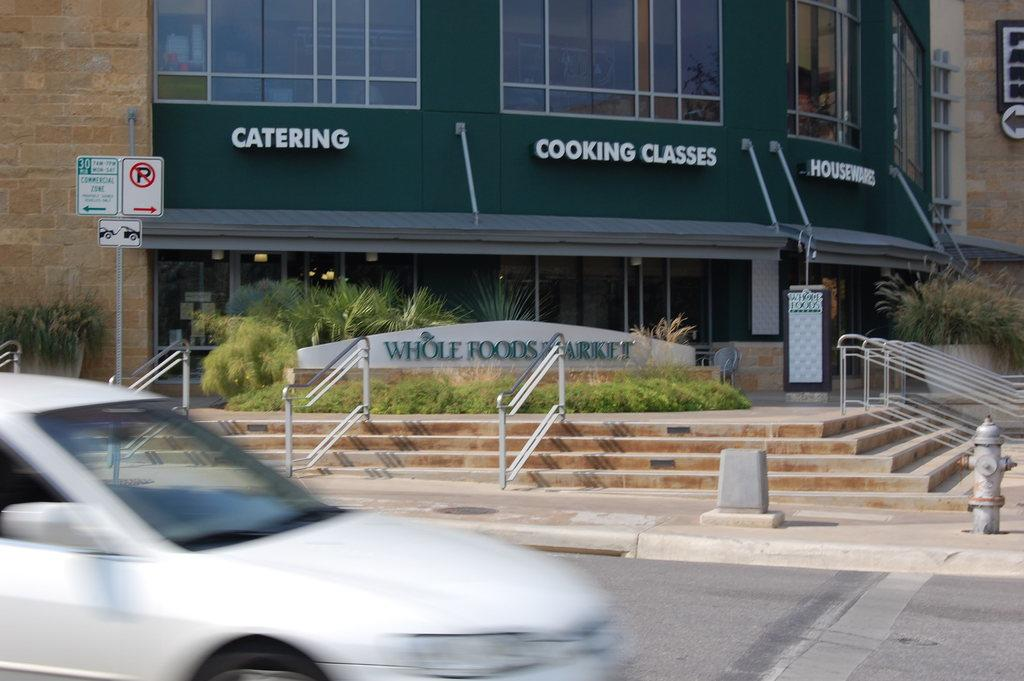What color is the car in the image? A: The car in the image is white. What can be seen in the background of the image? There is a building, stairs, railings, and plants in the background of the image. What is located in the middle of the image? There is a pole and two boards in the middle of the image. What type of meat is being served at the feast in the image? There is no feast or meat present in the image. How much sugar is being used to sweeten the car in the image? The car is not a food item and does not require sugar. 